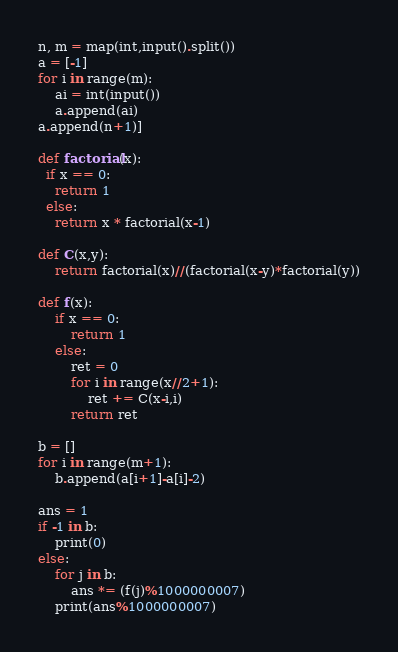<code> <loc_0><loc_0><loc_500><loc_500><_Python_>n, m = map(int,input().split())
a = [-1]
for i in range(m):
    ai = int(input())
    a.append(ai)
a.append(n+1)]

def factorial(x):
  if x == 0:
    return 1
  else:
    return x * factorial(x-1)

def C(x,y):
    return factorial(x)//(factorial(x-y)*factorial(y))

def f(x):
    if x == 0:
        return 1
    else:
        ret = 0
        for i in range(x//2+1):
            ret += C(x-i,i)
        return ret

b = []
for i in range(m+1):
    b.append(a[i+1]-a[i]-2)

ans = 1
if -1 in b:
    print(0)
else:
    for j in b:
        ans *= (f(j)%1000000007)
    print(ans%1000000007)</code> 